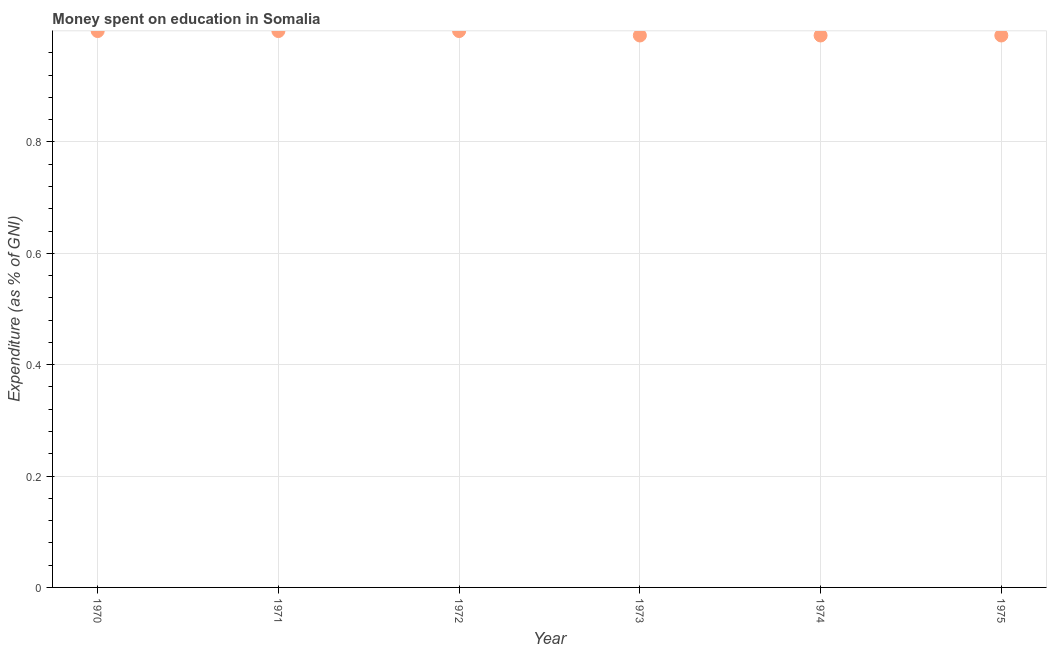What is the expenditure on education in 1972?
Your response must be concise. 1. Across all years, what is the maximum expenditure on education?
Ensure brevity in your answer.  1. Across all years, what is the minimum expenditure on education?
Your answer should be very brief. 0.99. In which year was the expenditure on education maximum?
Make the answer very short. 1970. What is the sum of the expenditure on education?
Your response must be concise. 5.97. What is the difference between the expenditure on education in 1974 and 1975?
Offer a very short reply. 0. What is the average expenditure on education per year?
Make the answer very short. 1. What is the median expenditure on education?
Your response must be concise. 1. Is the expenditure on education in 1971 less than that in 1972?
Provide a short and direct response. No. What is the difference between the highest and the second highest expenditure on education?
Keep it short and to the point. 0. What is the difference between the highest and the lowest expenditure on education?
Your answer should be compact. 0.01. In how many years, is the expenditure on education greater than the average expenditure on education taken over all years?
Your answer should be very brief. 3. How many years are there in the graph?
Provide a succinct answer. 6. Are the values on the major ticks of Y-axis written in scientific E-notation?
Offer a terse response. No. Does the graph contain any zero values?
Your answer should be compact. No. Does the graph contain grids?
Offer a terse response. Yes. What is the title of the graph?
Provide a succinct answer. Money spent on education in Somalia. What is the label or title of the Y-axis?
Your answer should be very brief. Expenditure (as % of GNI). What is the Expenditure (as % of GNI) in 1970?
Keep it short and to the point. 1. What is the Expenditure (as % of GNI) in 1971?
Your answer should be compact. 1. What is the Expenditure (as % of GNI) in 1972?
Offer a terse response. 1. What is the Expenditure (as % of GNI) in 1973?
Make the answer very short. 0.99. What is the Expenditure (as % of GNI) in 1974?
Your answer should be very brief. 0.99. What is the Expenditure (as % of GNI) in 1975?
Make the answer very short. 0.99. What is the difference between the Expenditure (as % of GNI) in 1970 and 1971?
Offer a terse response. 0. What is the difference between the Expenditure (as % of GNI) in 1970 and 1973?
Ensure brevity in your answer.  0.01. What is the difference between the Expenditure (as % of GNI) in 1970 and 1974?
Give a very brief answer. 0.01. What is the difference between the Expenditure (as % of GNI) in 1970 and 1975?
Offer a very short reply. 0.01. What is the difference between the Expenditure (as % of GNI) in 1971 and 1973?
Keep it short and to the point. 0.01. What is the difference between the Expenditure (as % of GNI) in 1971 and 1974?
Offer a terse response. 0.01. What is the difference between the Expenditure (as % of GNI) in 1971 and 1975?
Make the answer very short. 0.01. What is the difference between the Expenditure (as % of GNI) in 1972 and 1973?
Provide a short and direct response. 0.01. What is the difference between the Expenditure (as % of GNI) in 1972 and 1974?
Provide a short and direct response. 0.01. What is the difference between the Expenditure (as % of GNI) in 1972 and 1975?
Keep it short and to the point. 0.01. What is the difference between the Expenditure (as % of GNI) in 1974 and 1975?
Your answer should be very brief. 0. What is the ratio of the Expenditure (as % of GNI) in 1970 to that in 1971?
Offer a very short reply. 1. What is the ratio of the Expenditure (as % of GNI) in 1970 to that in 1972?
Your response must be concise. 1. What is the ratio of the Expenditure (as % of GNI) in 1970 to that in 1973?
Provide a succinct answer. 1.01. What is the ratio of the Expenditure (as % of GNI) in 1970 to that in 1975?
Provide a short and direct response. 1.01. What is the ratio of the Expenditure (as % of GNI) in 1971 to that in 1972?
Your answer should be very brief. 1. What is the ratio of the Expenditure (as % of GNI) in 1971 to that in 1974?
Offer a very short reply. 1.01. What is the ratio of the Expenditure (as % of GNI) in 1971 to that in 1975?
Your response must be concise. 1.01. What is the ratio of the Expenditure (as % of GNI) in 1972 to that in 1973?
Provide a short and direct response. 1.01. What is the ratio of the Expenditure (as % of GNI) in 1972 to that in 1974?
Provide a short and direct response. 1.01. What is the ratio of the Expenditure (as % of GNI) in 1972 to that in 1975?
Keep it short and to the point. 1.01. What is the ratio of the Expenditure (as % of GNI) in 1973 to that in 1974?
Give a very brief answer. 1. What is the ratio of the Expenditure (as % of GNI) in 1973 to that in 1975?
Offer a very short reply. 1. 